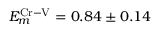Convert formula to latex. <formula><loc_0><loc_0><loc_500><loc_500>E _ { m } ^ { C r - V } = 0 . 8 4 \pm 0 . 1 4</formula> 